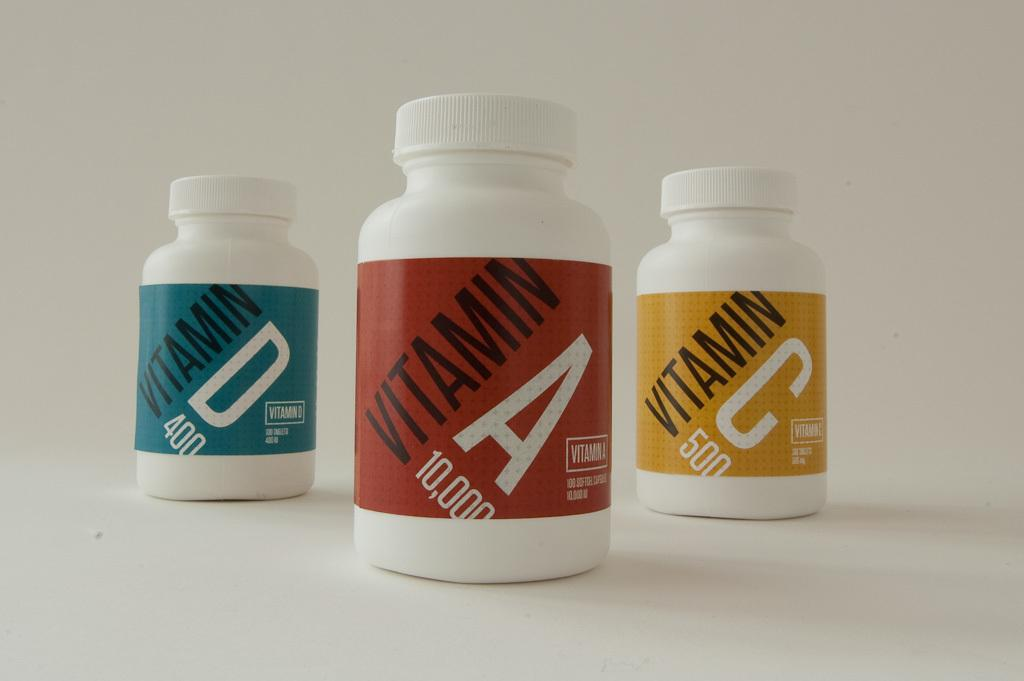<image>
Write a terse but informative summary of the picture. Bottle of red Vitamin A in between a bottle of Vitamin D and Vitamin C. 